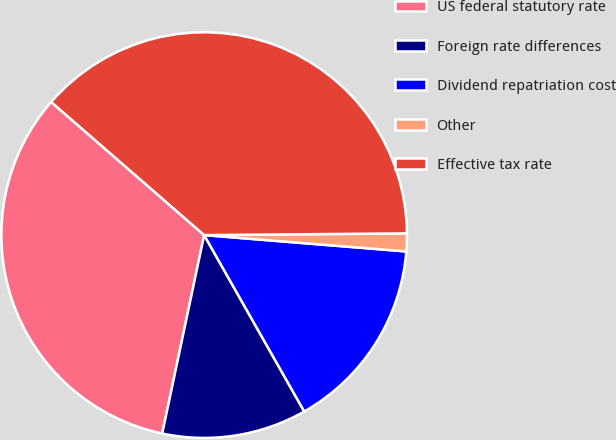Convert chart to OTSL. <chart><loc_0><loc_0><loc_500><loc_500><pie_chart><fcel>US federal statutory rate<fcel>Foreign rate differences<fcel>Dividend repatriation cost<fcel>Other<fcel>Effective tax rate<nl><fcel>33.08%<fcel>11.53%<fcel>15.5%<fcel>1.42%<fcel>38.47%<nl></chart> 